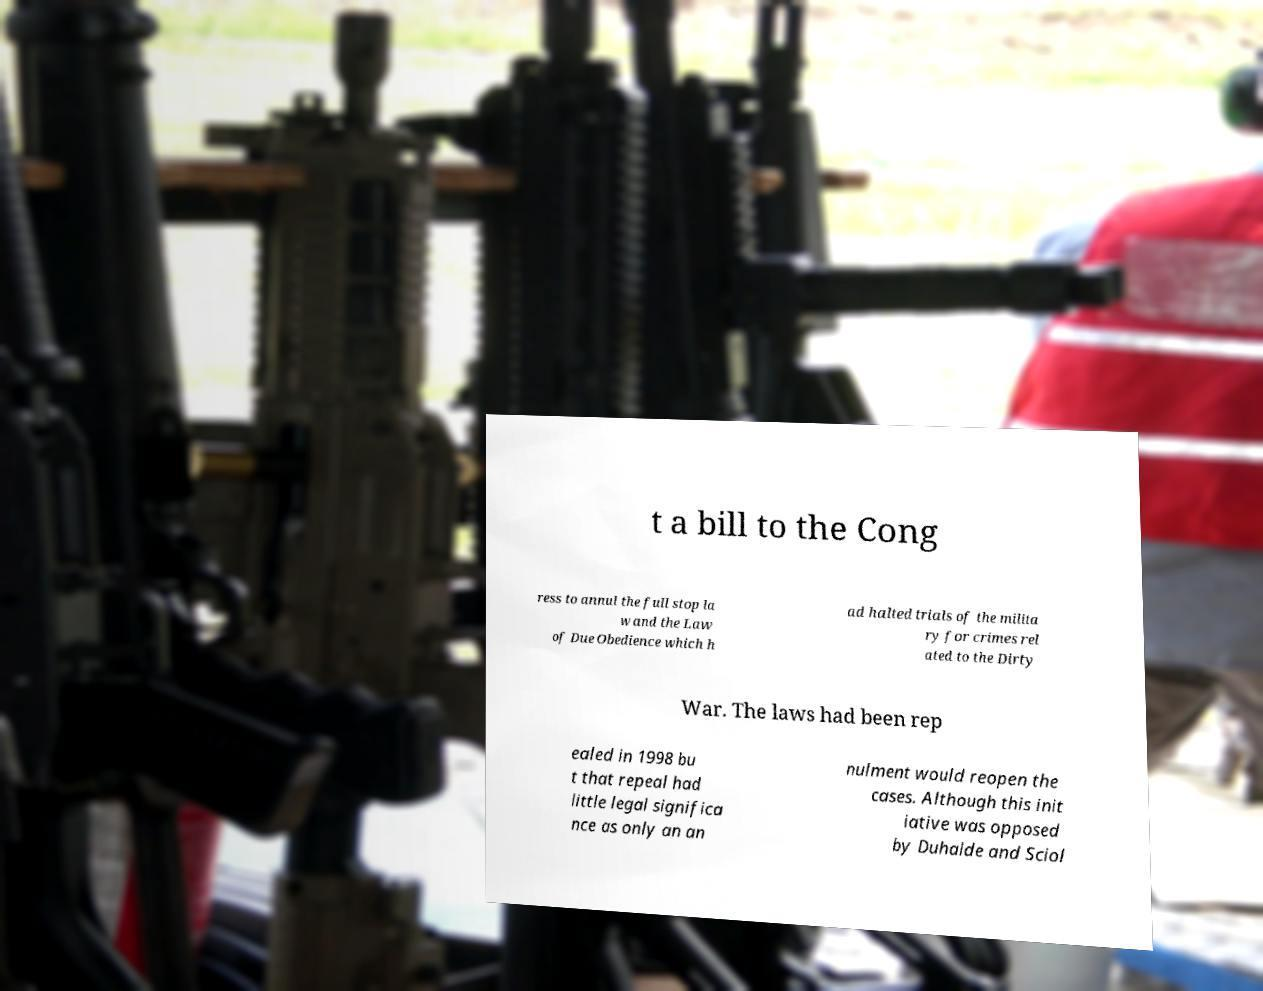Please read and relay the text visible in this image. What does it say? t a bill to the Cong ress to annul the full stop la w and the Law of Due Obedience which h ad halted trials of the milita ry for crimes rel ated to the Dirty War. The laws had been rep ealed in 1998 bu t that repeal had little legal significa nce as only an an nulment would reopen the cases. Although this init iative was opposed by Duhalde and Sciol 